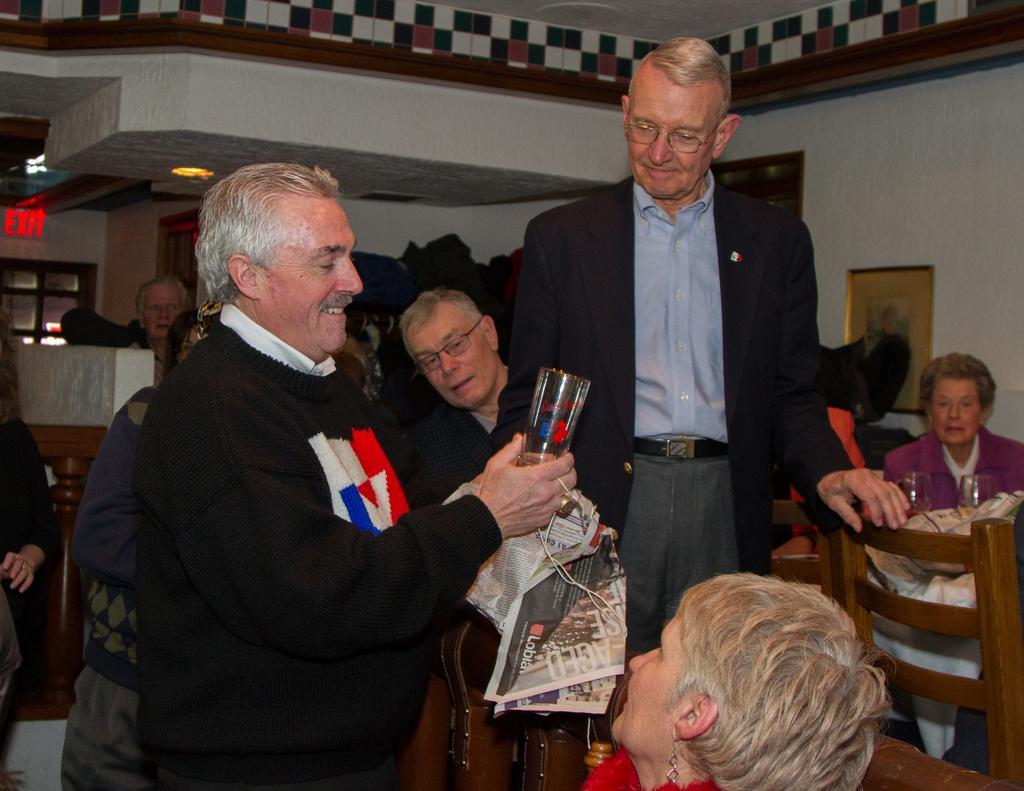Describe this image in one or two sentences. In this image we can see a group of people and one person is wearing a black color dress and holding a glass in his hand and other two persons are looking at him. On the right of the image we can see a lady is sitting on the chair. 